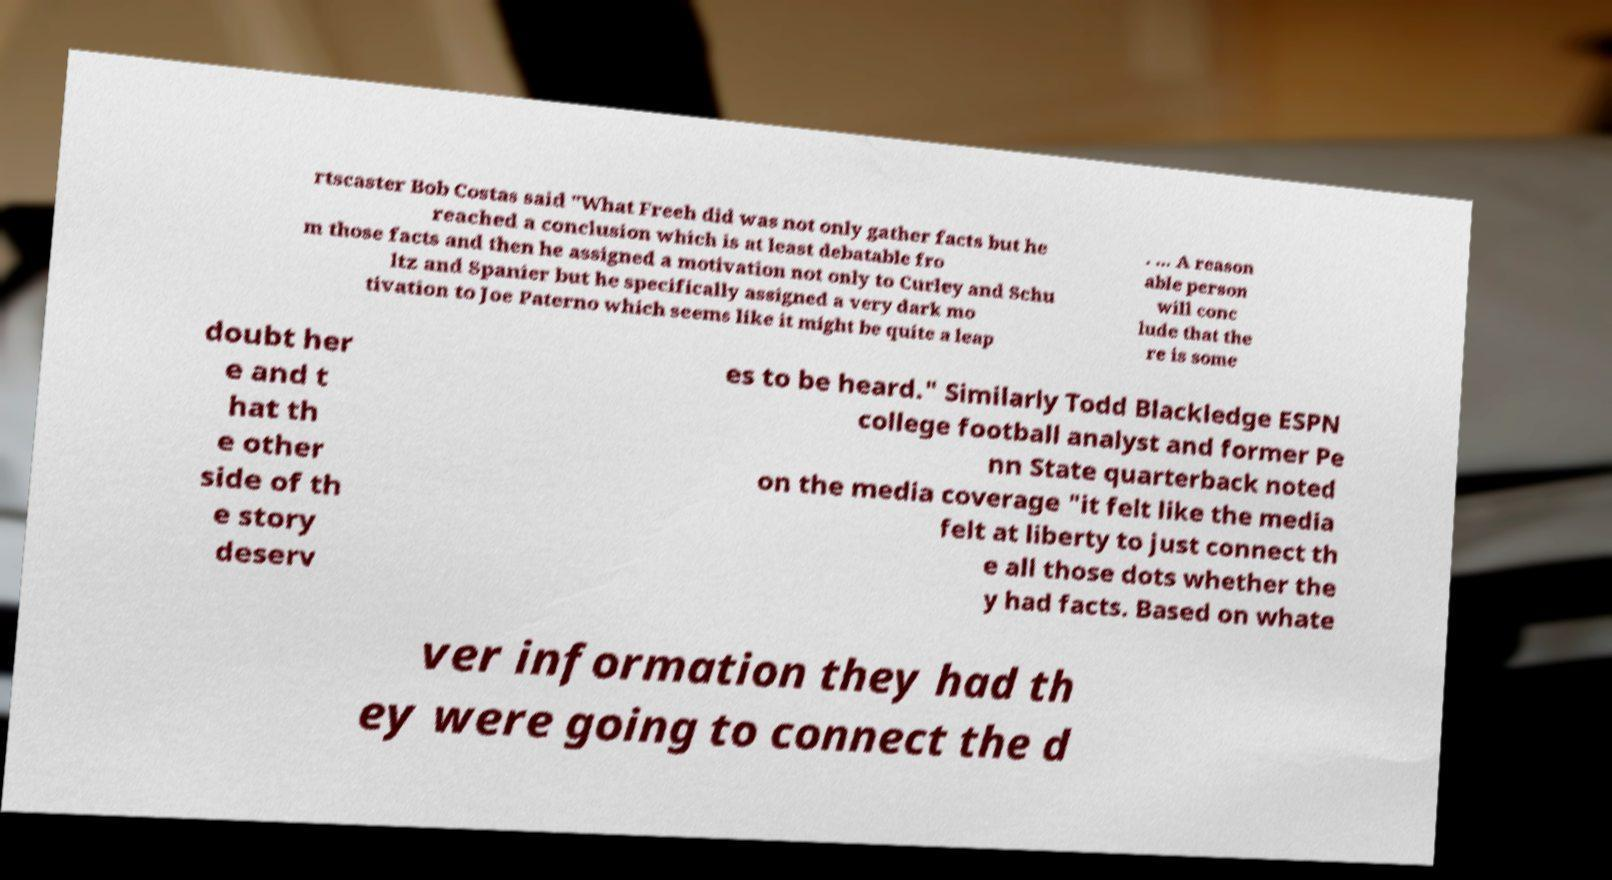Could you extract and type out the text from this image? rtscaster Bob Costas said "What Freeh did was not only gather facts but he reached a conclusion which is at least debatable fro m those facts and then he assigned a motivation not only to Curley and Schu ltz and Spanier but he specifically assigned a very dark mo tivation to Joe Paterno which seems like it might be quite a leap . ... A reason able person will conc lude that the re is some doubt her e and t hat th e other side of th e story deserv es to be heard." Similarly Todd Blackledge ESPN college football analyst and former Pe nn State quarterback noted on the media coverage "it felt like the media felt at liberty to just connect th e all those dots whether the y had facts. Based on whate ver information they had th ey were going to connect the d 